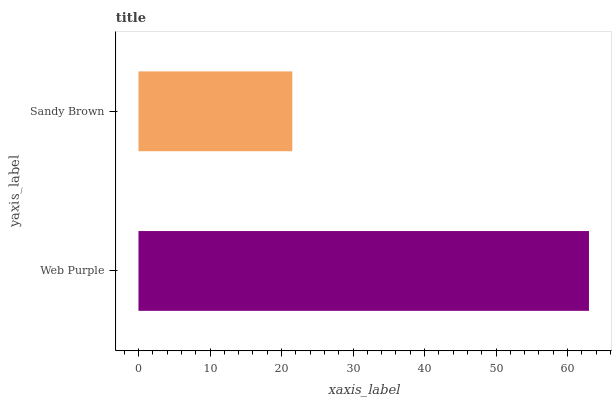Is Sandy Brown the minimum?
Answer yes or no. Yes. Is Web Purple the maximum?
Answer yes or no. Yes. Is Sandy Brown the maximum?
Answer yes or no. No. Is Web Purple greater than Sandy Brown?
Answer yes or no. Yes. Is Sandy Brown less than Web Purple?
Answer yes or no. Yes. Is Sandy Brown greater than Web Purple?
Answer yes or no. No. Is Web Purple less than Sandy Brown?
Answer yes or no. No. Is Web Purple the high median?
Answer yes or no. Yes. Is Sandy Brown the low median?
Answer yes or no. Yes. Is Sandy Brown the high median?
Answer yes or no. No. Is Web Purple the low median?
Answer yes or no. No. 